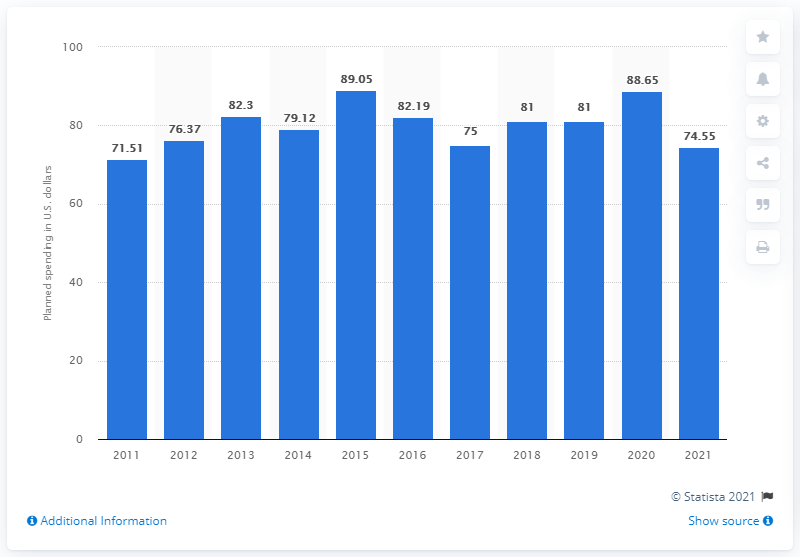Draw attention to some important aspects in this diagram. Adults planned to spend an average of 74.55 USD on Super Bowl Sunday. 